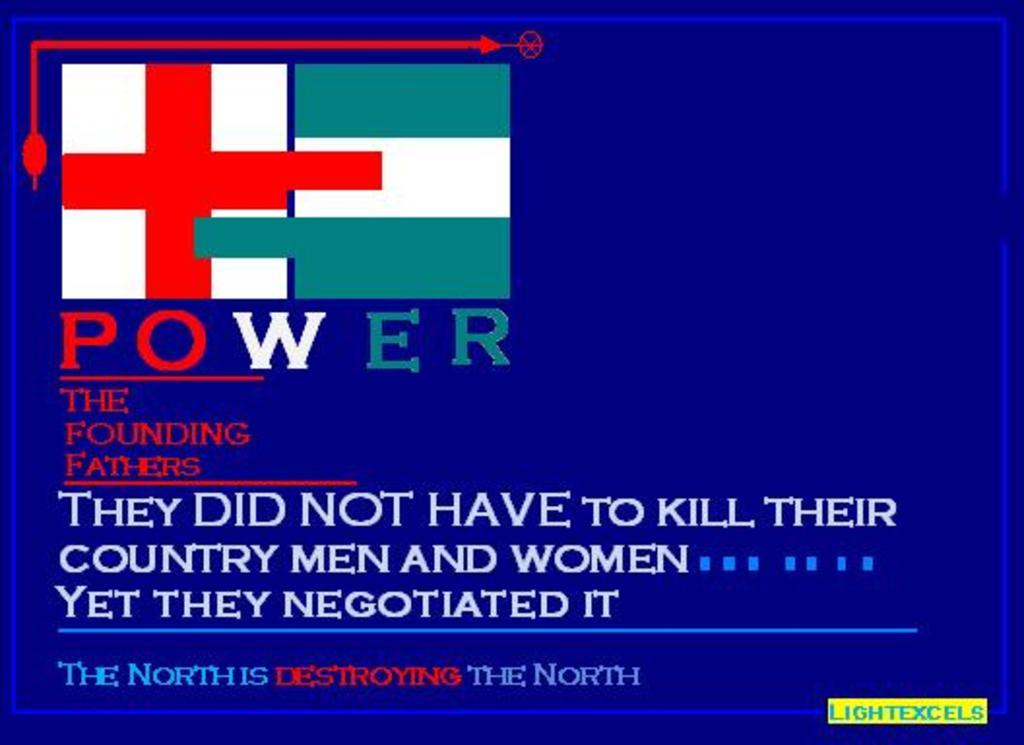What type of image is being described? The image is an edited graphic. What can be found at the top of the image? There is an icon on the top of the image. What is located below the icon? There is text below the icon. Where is the faucet located in the image? There is no faucet present in the image. What type of underwear is being worn by the icon in the image? There is no icon or underwear depicted in the image. 